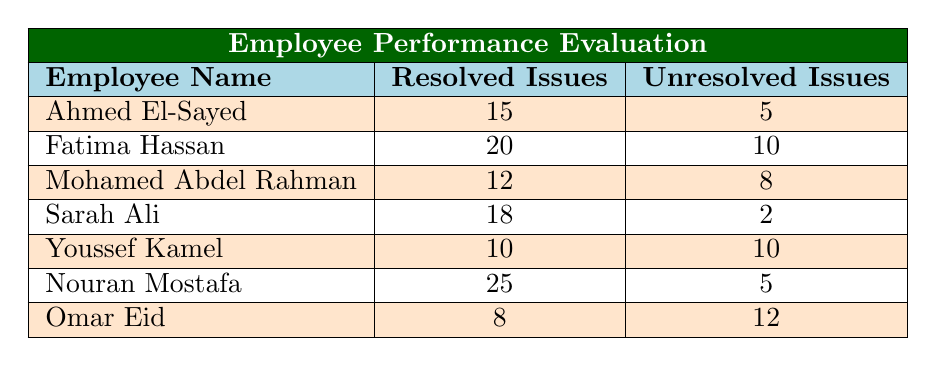What is the highest number of resolved issues among employees? Looking at the "Resolved Issues" column, Nouran Mostafa has the highest number with 25 resolved issues.
Answer: 25 Who has the lowest number of unresolved issues? Examining the "Unresolved Issues" column, Sarah Ali has the lowest with only 2 unresolved issues.
Answer: 2 What is the total number of unresolved issues across all employees? Summing the unresolved issues: 5 + 10 + 8 + 2 + 10 + 5 + 12 = 52 unresolved issues in total.
Answer: 52 Is Fatima Hassan more effective in resolving issues than Ahmed El-Sayed? Fatima resolved 20 issues while Ahmed resolved 15. Thus, Fatima is more effective in resolving issues than Ahmed.
Answer: Yes What is the average number of resolved issues for all employees? The total resolved issues are 15 + 20 + 12 + 18 + 10 + 25 + 8 = 108. Dividing this by 7 employees gives an average of 108/7 ≈ 15.43.
Answer: Approximately 15.43 Which employee has the highest difference between resolved and unresolved issues? For each employee, calculate the difference: Nouran (25-5=20), Sarah (18-2=16), Fatima (20-10=10), Ahmed (15-5=10), Mohamed (12-8=4), Youssef (10-10=0), and Omar (8-12=-4). Nouran has the highest difference of 20.
Answer: Nouran Mostafa Are there any employees with an equal number of resolved and unresolved issues? Reviewing the table, Youssef Kamel has 10 resolved and 10 unresolved issues, which means he has an equal number in both categories.
Answer: Yes 